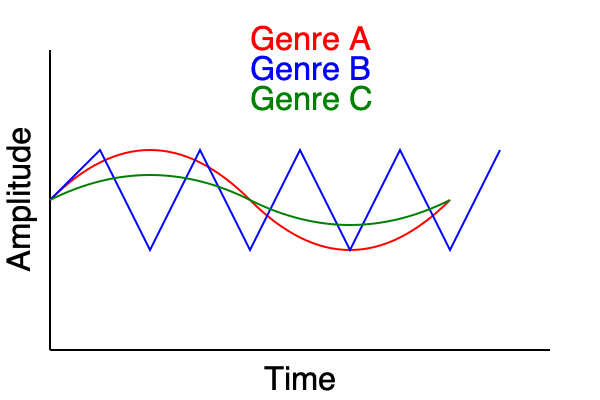Analyze the waveform patterns shown in the graph for Genres A, B, and C. Which genre is most likely to represent a Dubstep track, and why? Explain your reasoning based on the characteristics of Dubstep and the waveform properties. To determine which genre is most likely to represent a Dubstep track, we need to analyze the waveform patterns and compare them to the typical characteristics of Dubstep music:

1. Dubstep characteristics:
   - Heavy bass and sub-bass frequencies
   - Rhythmic, often syncopated drum patterns
   - Sudden, dramatic changes in tempo and intensity
   - "Wobble" bass effect

2. Analyzing the waveforms:
   - Genre A (red): Smooth, sinusoidal wave with gradual changes in amplitude
   - Genre B (blue): Sharp, sawtooth-like pattern with consistent, rapid changes in amplitude
   - Genre C (green): Irregular wave with sudden changes in amplitude and direction

3. Comparing waveforms to Dubstep characteristics:
   - Genre A: Too smooth and regular for Dubstep
   - Genre B: Consistent pattern doesn't match Dubstep's varying intensity
   - Genre C: Shows sudden changes in amplitude and direction, consistent with Dubstep's "wobble" bass and dramatic shifts

4. Reasoning:
   - The irregular pattern and sudden changes in Genre C's waveform most closely align with Dubstep's characteristics
   - These changes likely represent the "wobble" bass effect and dramatic shifts in intensity typical of Dubstep
   - The waveform suggests varying bass frequencies and rhythmic patterns consistent with Dubstep production techniques

Therefore, Genre C is most likely to represent a Dubstep track due to its irregular waveform pattern and sudden changes in amplitude, which align with the genre's characteristic "wobble" bass effect and dramatic shifts in intensity.
Answer: Genre C (green waveform) 